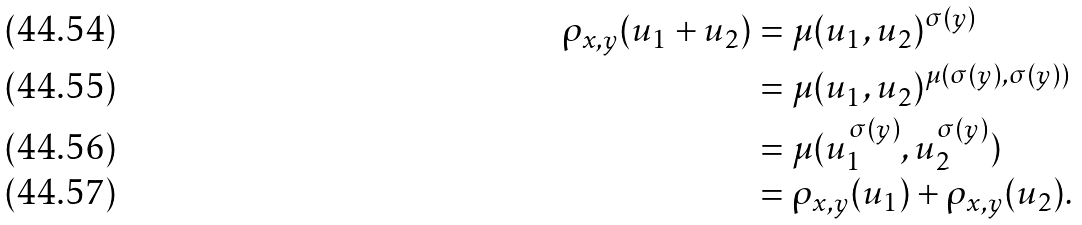<formula> <loc_0><loc_0><loc_500><loc_500>\rho _ { x , y } ( u _ { 1 } + u _ { 2 } ) & = \mu ( u _ { 1 } , u _ { 2 } ) ^ { \sigma ( y ) } \\ & = \mu ( u _ { 1 } , u _ { 2 } ) ^ { \mu ( \sigma ( y ) , \sigma ( y ) ) } \\ & = \mu ( u _ { 1 } ^ { \sigma ( y ) } , u _ { 2 } ^ { \sigma ( y ) } ) \\ & = \rho _ { x , y } ( u _ { 1 } ) + \rho _ { x , y } ( u _ { 2 } ) .</formula> 